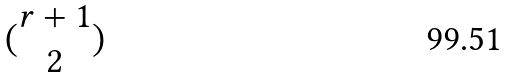<formula> <loc_0><loc_0><loc_500><loc_500>( \begin{matrix} r + 1 \\ 2 \end{matrix} )</formula> 